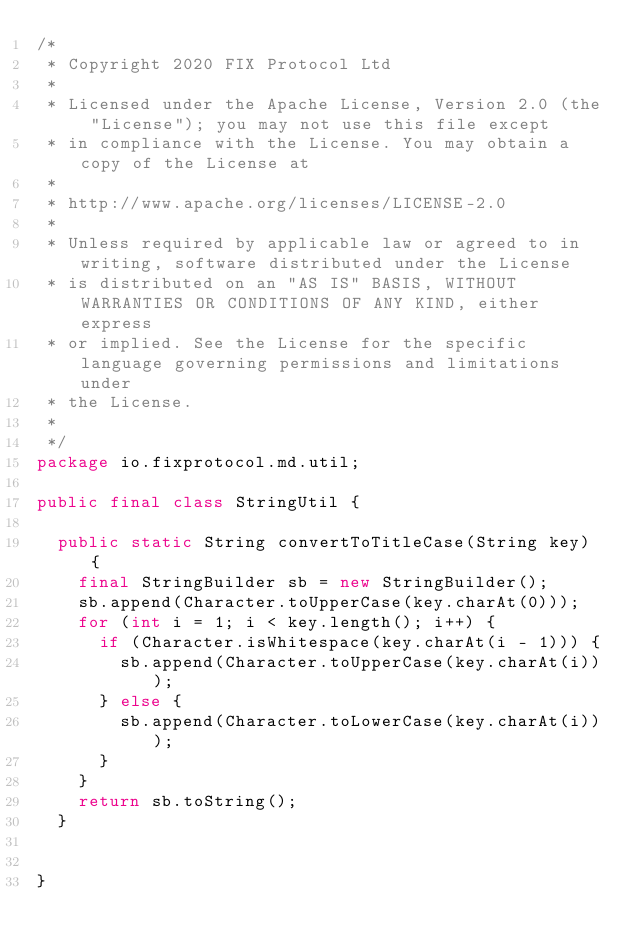Convert code to text. <code><loc_0><loc_0><loc_500><loc_500><_Java_>/*
 * Copyright 2020 FIX Protocol Ltd
 *
 * Licensed under the Apache License, Version 2.0 (the "License"); you may not use this file except
 * in compliance with the License. You may obtain a copy of the License at
 *
 * http://www.apache.org/licenses/LICENSE-2.0
 *
 * Unless required by applicable law or agreed to in writing, software distributed under the License
 * is distributed on an "AS IS" BASIS, WITHOUT WARRANTIES OR CONDITIONS OF ANY KIND, either express
 * or implied. See the License for the specific language governing permissions and limitations under
 * the License.
 *
 */
package io.fixprotocol.md.util;

public final class StringUtil {

  public static String convertToTitleCase(String key) {
    final StringBuilder sb = new StringBuilder();
    sb.append(Character.toUpperCase(key.charAt(0)));
    for (int i = 1; i < key.length(); i++) {
      if (Character.isWhitespace(key.charAt(i - 1))) {
        sb.append(Character.toUpperCase(key.charAt(i)));
      } else {
        sb.append(Character.toLowerCase(key.charAt(i)));
      }
    }
    return sb.toString();
  }


}
</code> 